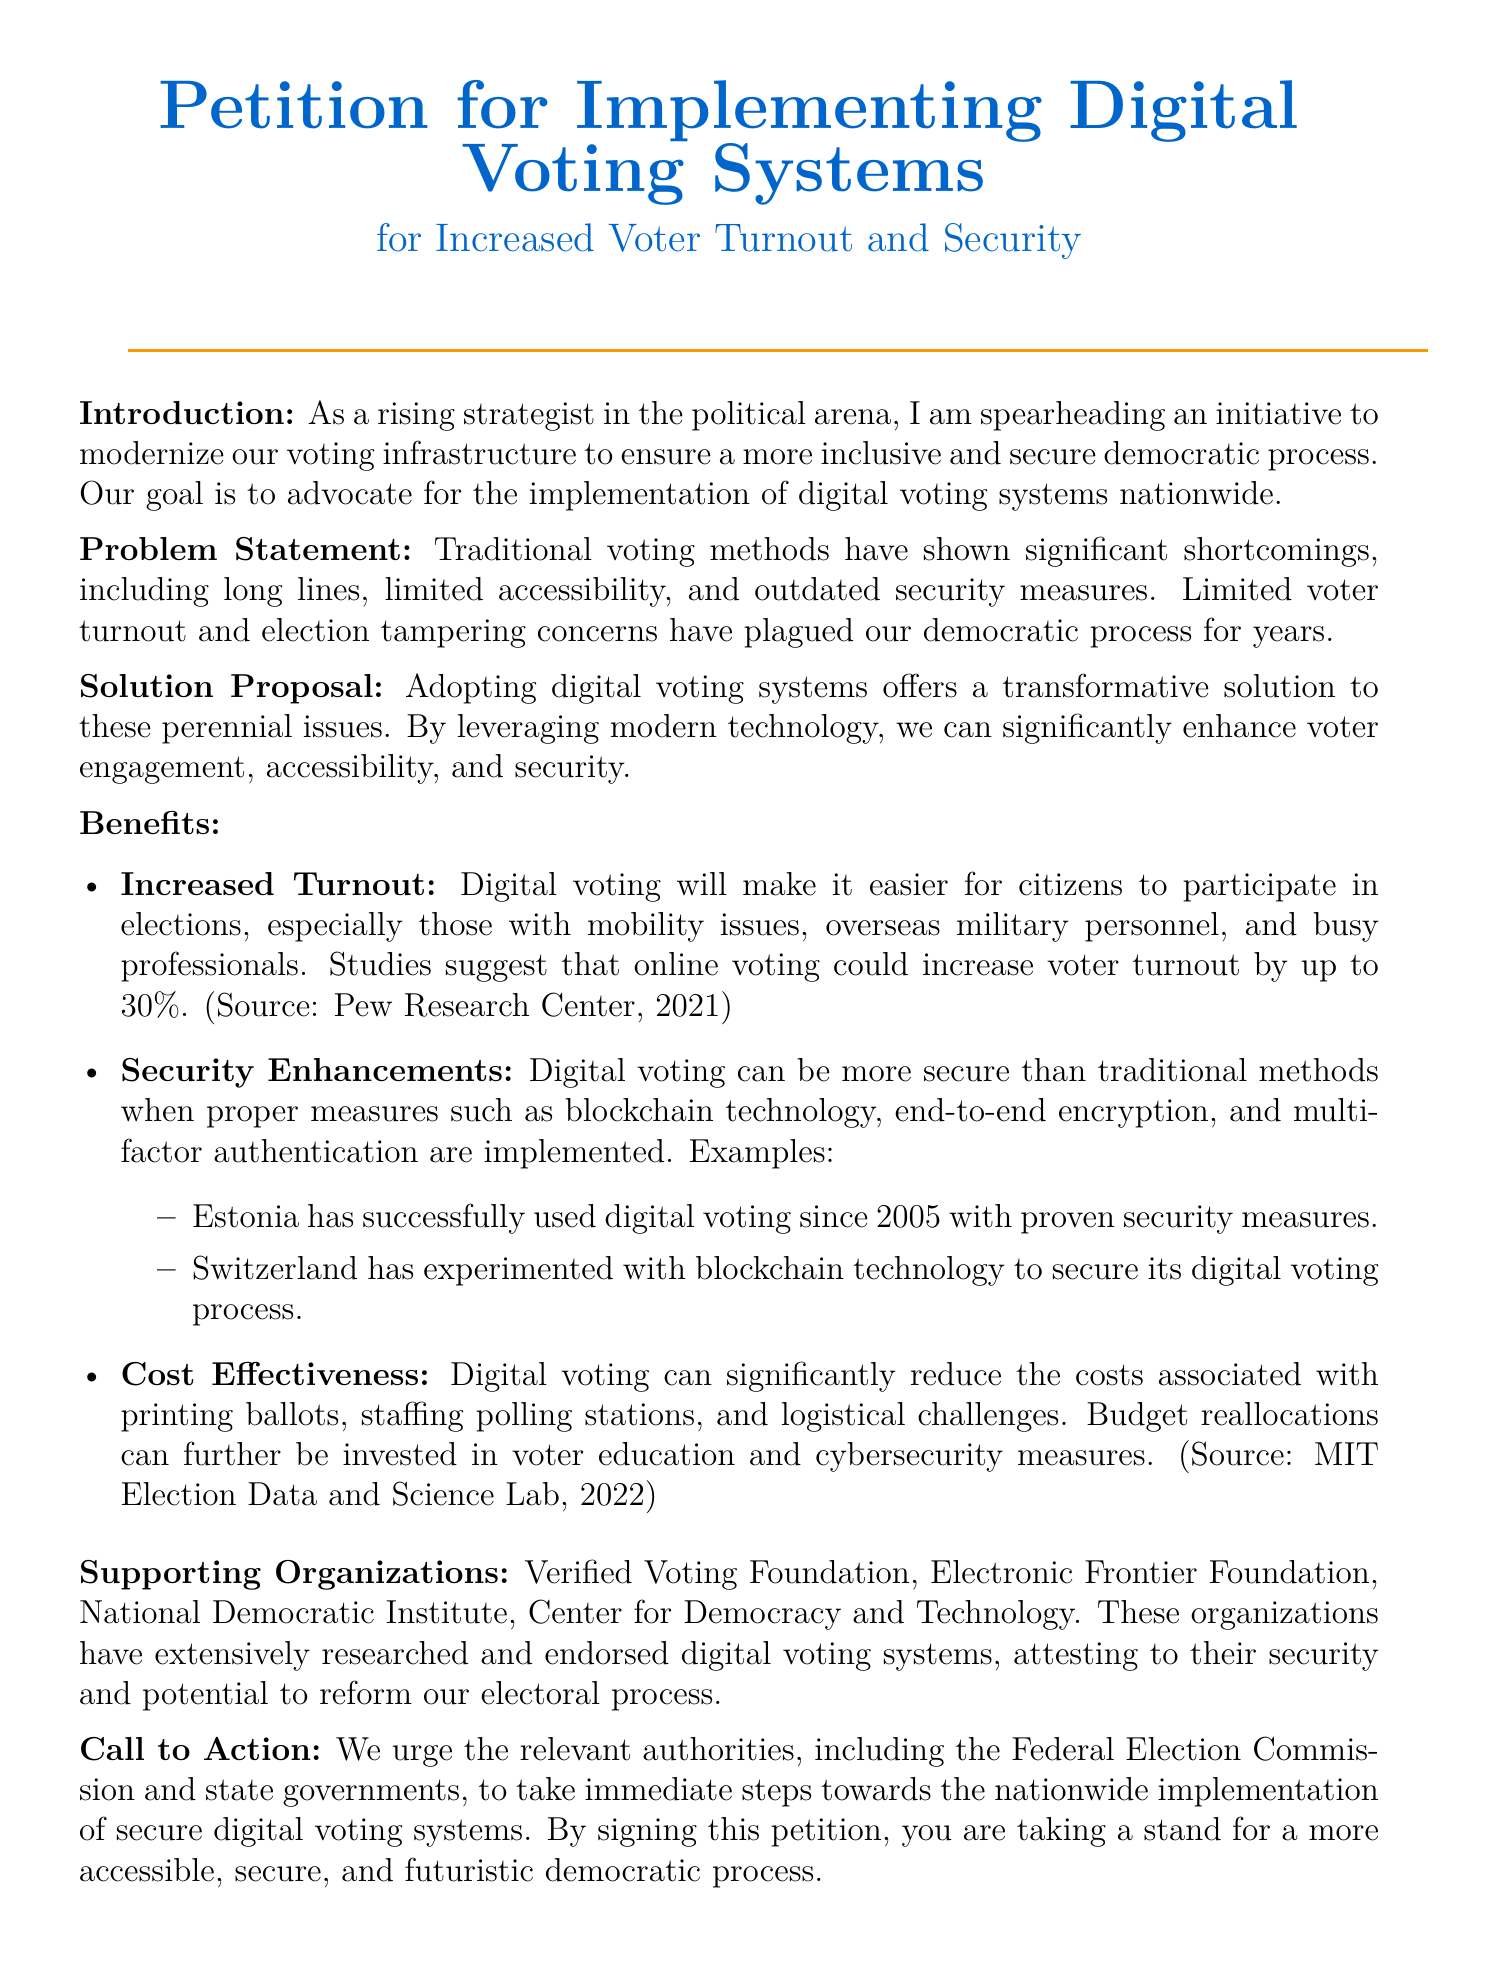What is the main goal of the petition? The main goal of the petition is to advocate for the implementation of digital voting systems nationwide.
Answer: To advocate for digital voting systems nationwide What organization endorsed digital voting systems? The document lists several organizations that support digital voting systems, one of which is the Verified Voting Foundation.
Answer: Verified Voting Foundation Since what year has Estonia used digital voting? The petition states that Estonia has successfully used digital voting since 2005.
Answer: Since 2005 By how much could online voting potentially increase voter turnout? The document mentions that studies suggest online voting could increase voter turnout by up to 30 percent.
Answer: Up to 30 percent What technological measures are suggested for digital voting security? Suggestions for security measures include blockchain technology, end-to-end encryption, and multi-factor authentication.
Answer: Blockchain technology, end-to-end encryption, and multi-factor authentication What problem does traditional voting methods face? The document highlights significant shortcomings in traditional voting methods, including long lines and limited accessibility.
Answer: Long lines and limited accessibility What is the proposed solution to voter engagement issues? The proposed solution to voter engagement issues is the adoption of digital voting systems.
Answer: Adoption of digital voting systems Who should take immediate steps towards implementing digital voting systems? The petition urges the Federal Election Commission and state governments to take immediate steps.
Answer: Federal Election Commission and state governments 